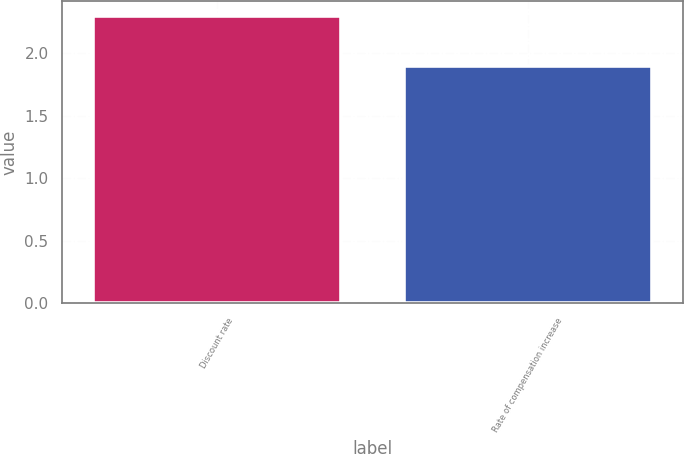Convert chart to OTSL. <chart><loc_0><loc_0><loc_500><loc_500><bar_chart><fcel>Discount rate<fcel>Rate of compensation increase<nl><fcel>2.3<fcel>1.9<nl></chart> 